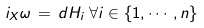Convert formula to latex. <formula><loc_0><loc_0><loc_500><loc_500>i _ { X } \omega \, = \, d H _ { i } \, \forall i \in \{ 1 , \cdots , n \}</formula> 